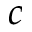Convert formula to latex. <formula><loc_0><loc_0><loc_500><loc_500>c</formula> 